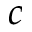Convert formula to latex. <formula><loc_0><loc_0><loc_500><loc_500>c</formula> 